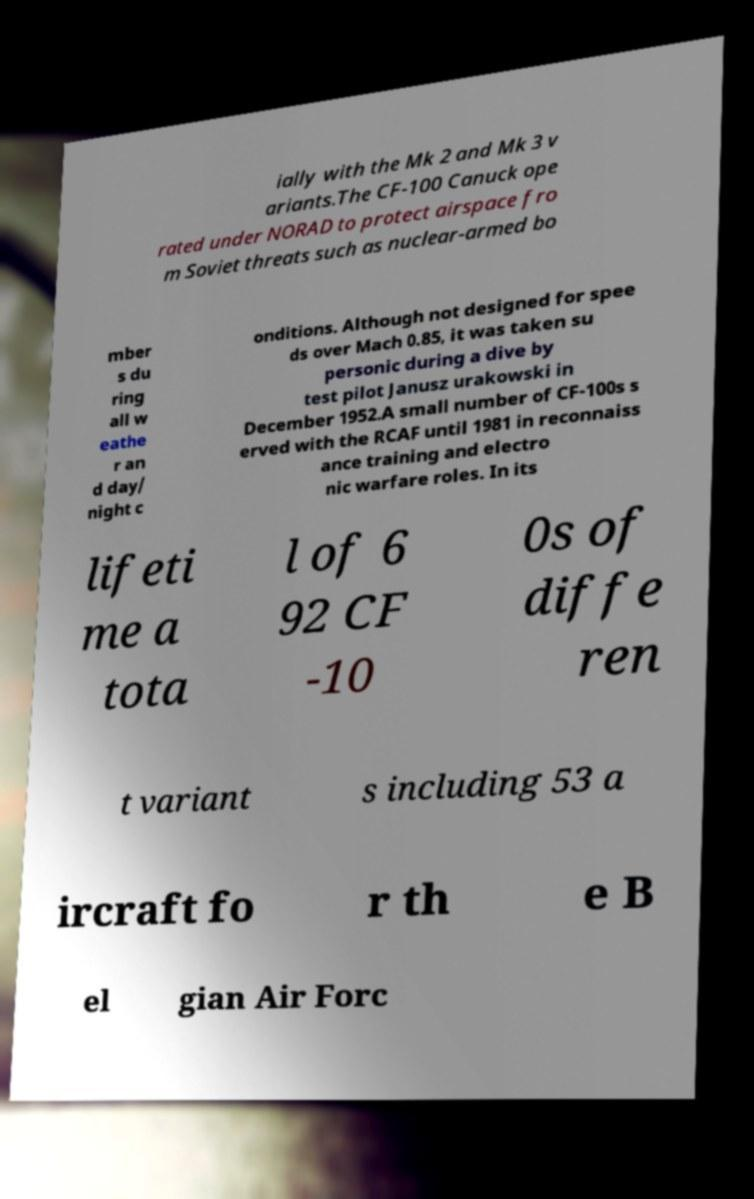Could you extract and type out the text from this image? ially with the Mk 2 and Mk 3 v ariants.The CF-100 Canuck ope rated under NORAD to protect airspace fro m Soviet threats such as nuclear-armed bo mber s du ring all w eathe r an d day/ night c onditions. Although not designed for spee ds over Mach 0.85, it was taken su personic during a dive by test pilot Janusz urakowski in December 1952.A small number of CF-100s s erved with the RCAF until 1981 in reconnaiss ance training and electro nic warfare roles. In its lifeti me a tota l of 6 92 CF -10 0s of diffe ren t variant s including 53 a ircraft fo r th e B el gian Air Forc 